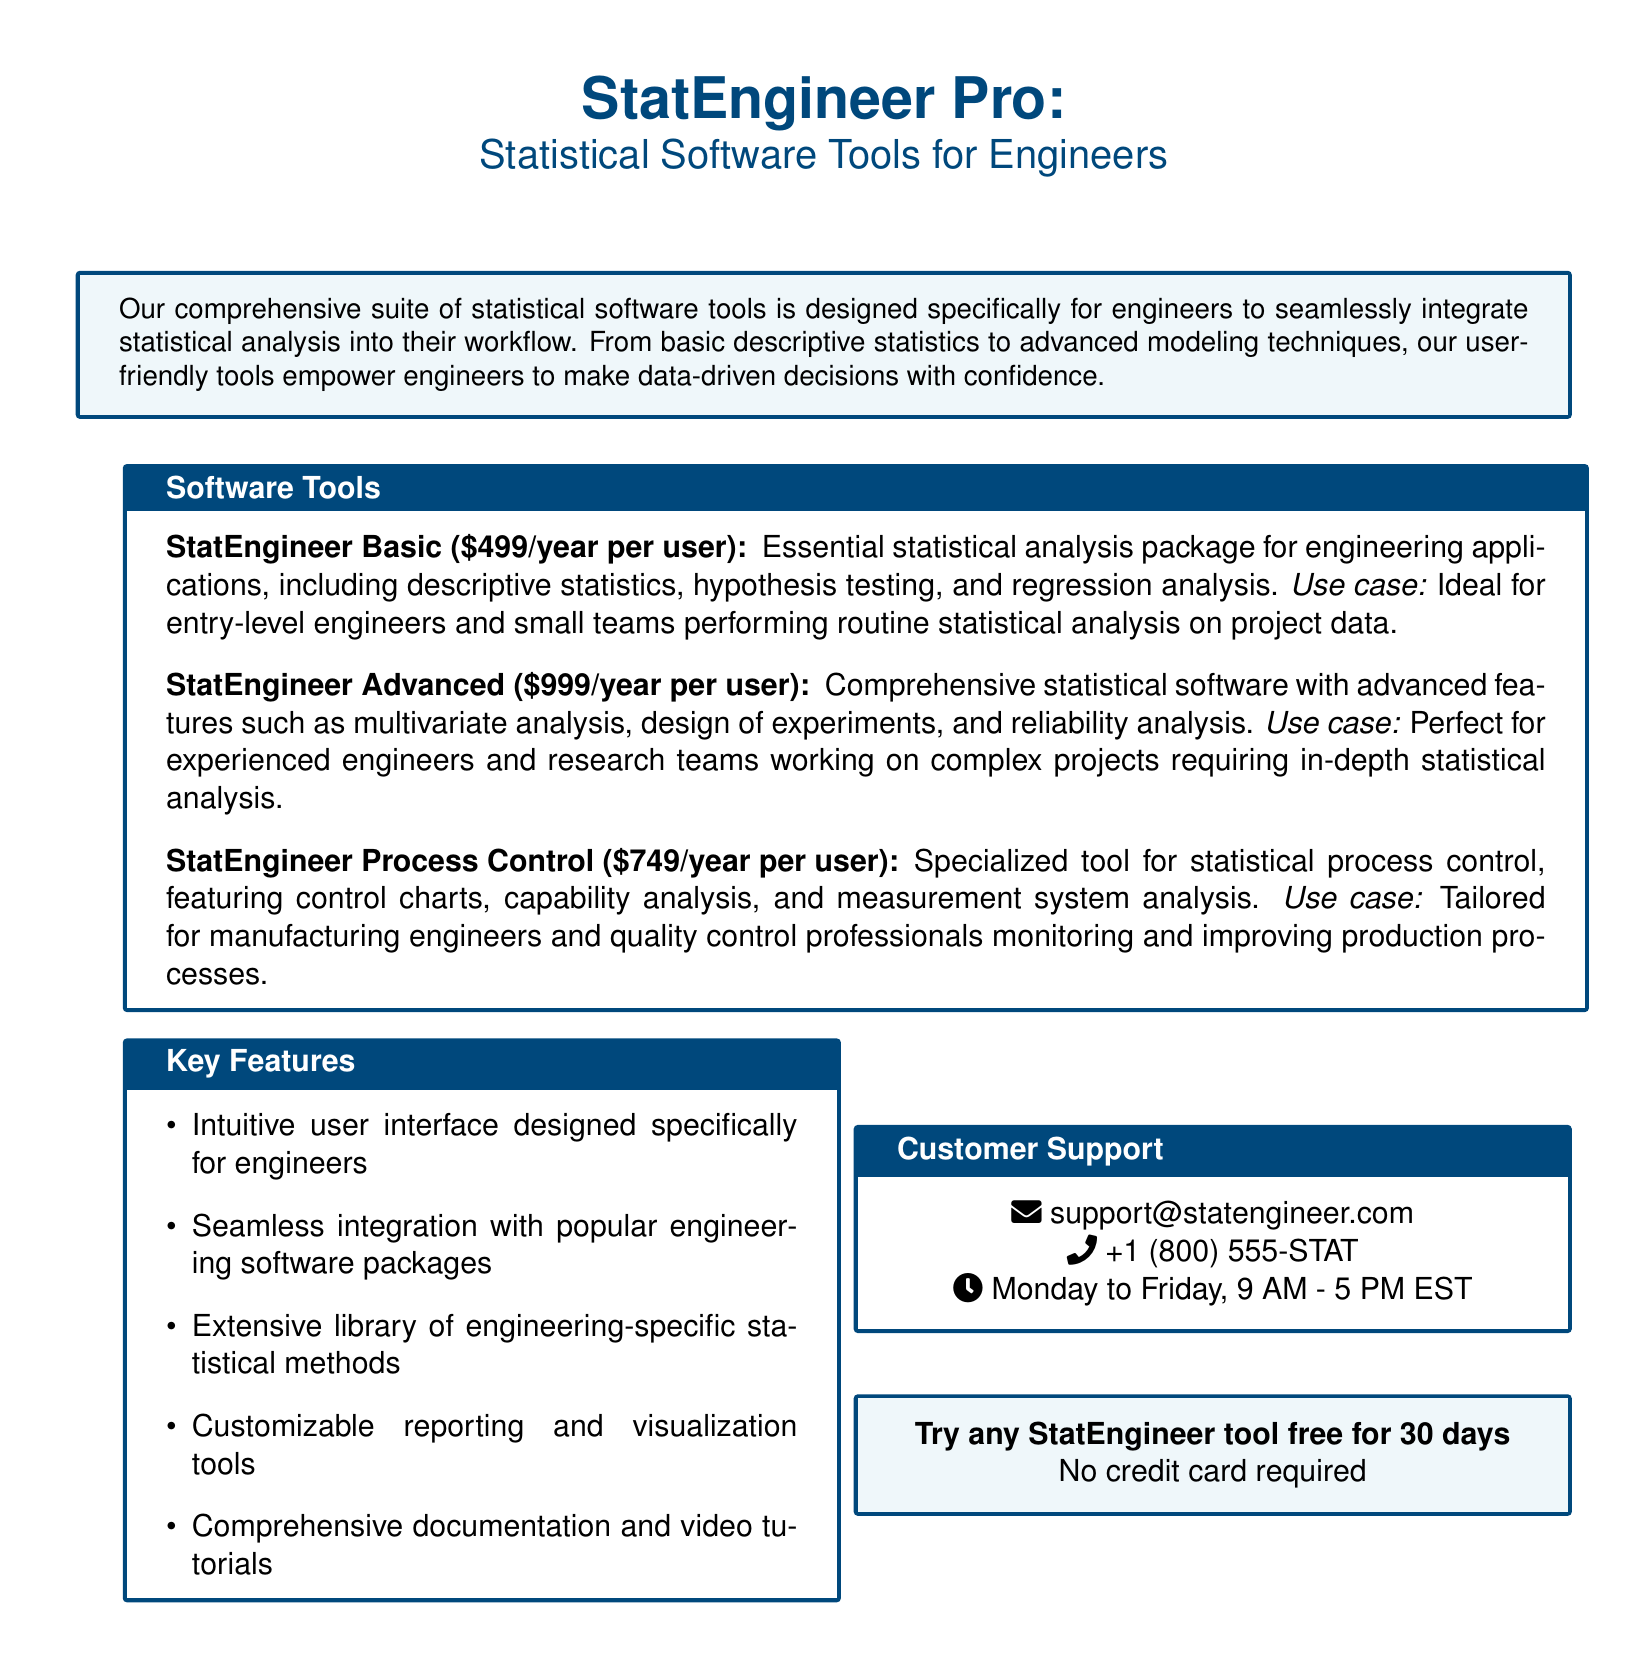what is the price of StatEngineer Basic? The price of StatEngineer Basic is listed as $499 per year per user.
Answer: $499/year per user how many StatEngineer tools are mentioned? There are three different StatEngineer tools described in the document.
Answer: three what is the use case for StatEngineer Advanced? The use case for StatEngineer Advanced is detailed for experienced engineers and research teams working on complex projects requiring in-depth statistical analysis.
Answer: Perfect for experienced engineers and research teams what is the customer support phone number? The customer support phone number is provided in the document as +1 (800) 555-STAT.
Answer: +1 (800) 555-STAT what is included in the key features section? The key features section lists various capabilities of the software tools tailored for engineers, like an intuitive user interface and extensive statistical methods.
Answer: Intuitive user interface designed specifically for engineers what is the price for StatEngineer Process Control? The document states that StatEngineer Process Control costs $749 per year per user.
Answer: $749/year per user what does the free trial offer entail? The free trial offer mentioned in the document states that any StatEngineer tool can be tried free for 30 days with no credit card required.
Answer: Try any StatEngineer tool free for 30 days what is the main purpose of the software tools described? The main purpose of the software tools is to empower engineers to make data-driven decisions with confidence through statistical analysis.
Answer: Seamlessly integrate statistical analysis into their workflow who is the target audience for StatEngineer tools? The target audience for StatEngineer tools primarily includes engineers and engineering teams.
Answer: engineers 